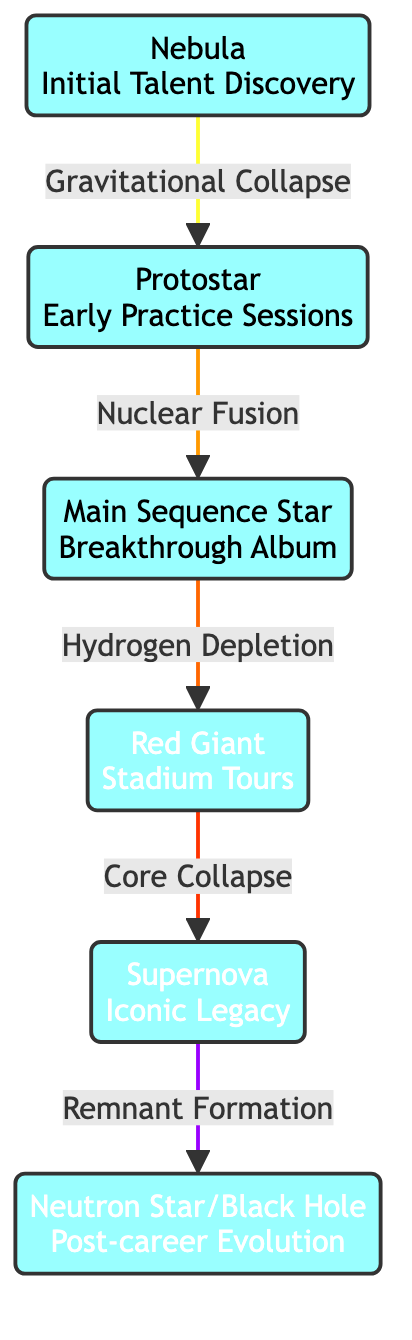What is the first stage in the life cycle of a star? The diagram shows the first node labeled "Nebula," which represents the initial stage of a star's life cycle.
Answer: Nebula How many stages are there in the life cycle of a star as shown in the diagram? By counting the nodes in the diagram, we find there are six distinct stages: Nebula, Protostar, Main Sequence Star, Red Giant, Supernova, and Neutron Star/Black Hole.
Answer: Six What label describes the stage following the Main Sequence Star? The diagram indicates that the stage directly following "Main Sequence Star" is labeled "Red Giant."
Answer: Red Giant What analogy does the Supernova stage represent in a music career? According to the diagram, the Supernova stage is analogous to "Iconic Legacy," which suggests the significant and lasting impact an artist has during their career.
Answer: Iconic Legacy What is the relationship between the Red Giant and Supernova stages? The diagram connects these two stages with an arrow that notes "Core Collapse," indicating that the Red Giant undergoes a core collapse leading to the Supernova.
Answer: Core Collapse How does a Protostar evolve into a Main Sequence Star? The flow from "Protostar" to "Main Sequence Star" is completed through "Nuclear Fusion," which signifies the process that allows a star to achieve the main sequence phase.
Answer: Nuclear Fusion At which stage does a star become a powerhouse in its life cycle? The label "Main Sequence Star" refers to the stage when a star is primarily undergoing nuclear fusion and can be considered a powerhouse of energy.
Answer: Main Sequence Star In the life cycle of a star, what follows after a Supernova? The diagram shows that the stage that comes after "Supernova" is "Neutron Star/Black Hole," indicating the remnants of a star's explosive end.
Answer: Neutron Star/Black Hole What stage relates to "Stadium Tours" in a music career analogy? The "Red Giant" stage in the diagram represents "Stadium Tours," paralleling the idea of a musician reaching a peak phase of popularity and touring extensively.
Answer: Stadium Tours 